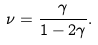Convert formula to latex. <formula><loc_0><loc_0><loc_500><loc_500>\nu = \frac { \gamma } { 1 - 2 \gamma } .</formula> 